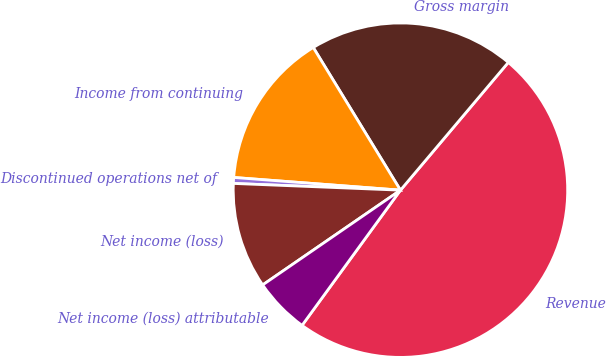<chart> <loc_0><loc_0><loc_500><loc_500><pie_chart><fcel>Revenue<fcel>Gross margin<fcel>Income from continuing<fcel>Discontinued operations net of<fcel>Net income (loss)<fcel>Net income (loss) attributable<nl><fcel>48.86%<fcel>19.89%<fcel>15.06%<fcel>0.57%<fcel>10.23%<fcel>5.4%<nl></chart> 